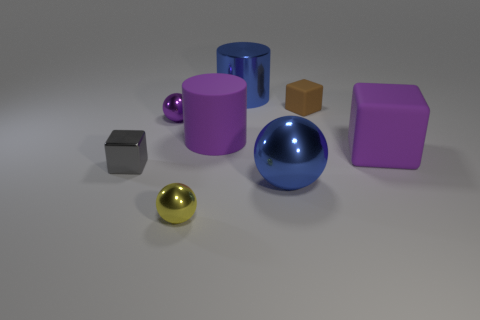Is the material of the tiny cube in front of the small brown cube the same as the large ball?
Make the answer very short. Yes. Do the large cube and the shiny sphere that is behind the gray object have the same color?
Your answer should be very brief. Yes. There is a yellow object; are there any large purple matte blocks in front of it?
Make the answer very short. No. Is the size of the block that is to the left of the tiny yellow ball the same as the metal sphere behind the large blue metal sphere?
Offer a terse response. Yes. Are there any green metallic cubes of the same size as the brown thing?
Your response must be concise. No. There is a small thing to the right of the small yellow thing; is it the same shape as the tiny gray metallic thing?
Make the answer very short. Yes. There is a large purple thing on the left side of the large purple block; what is it made of?
Your answer should be compact. Rubber. What shape is the purple object that is left of the small metallic thing that is in front of the tiny gray metal cube?
Give a very brief answer. Sphere. Do the tiny yellow thing and the blue metallic thing that is in front of the gray block have the same shape?
Your response must be concise. Yes. There is a big blue object in front of the small purple thing; what number of large shiny things are behind it?
Give a very brief answer. 1. 